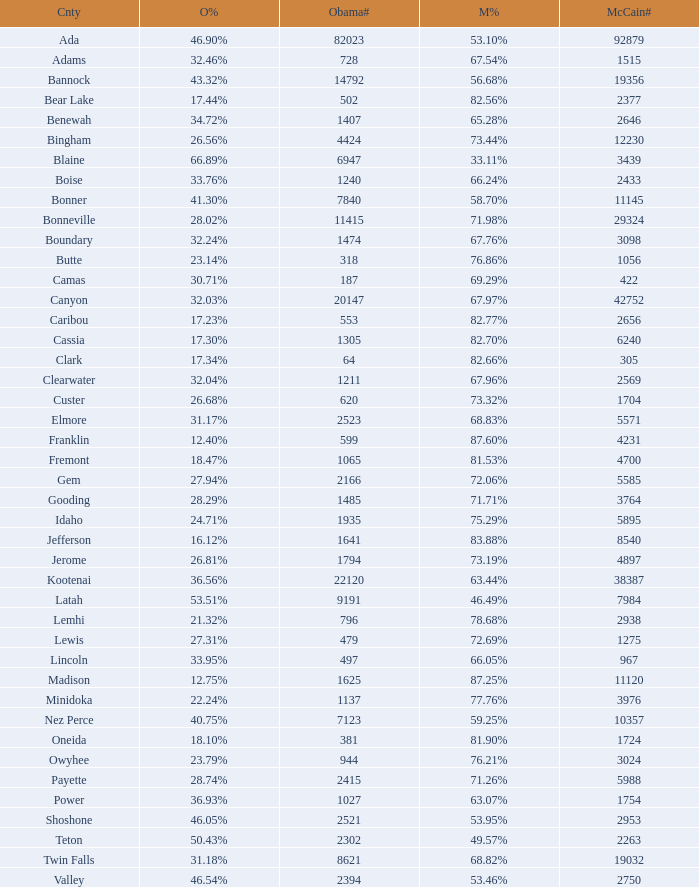What is the total number of McCain vote totals where Obama percentages was 17.34%? 1.0. 